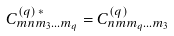Convert formula to latex. <formula><loc_0><loc_0><loc_500><loc_500>C _ { m n m _ { 3 } \dots m _ { q } } ^ { ( q ) \, * } = C _ { n m m _ { q } \dots m _ { 3 } } ^ { ( q ) }</formula> 